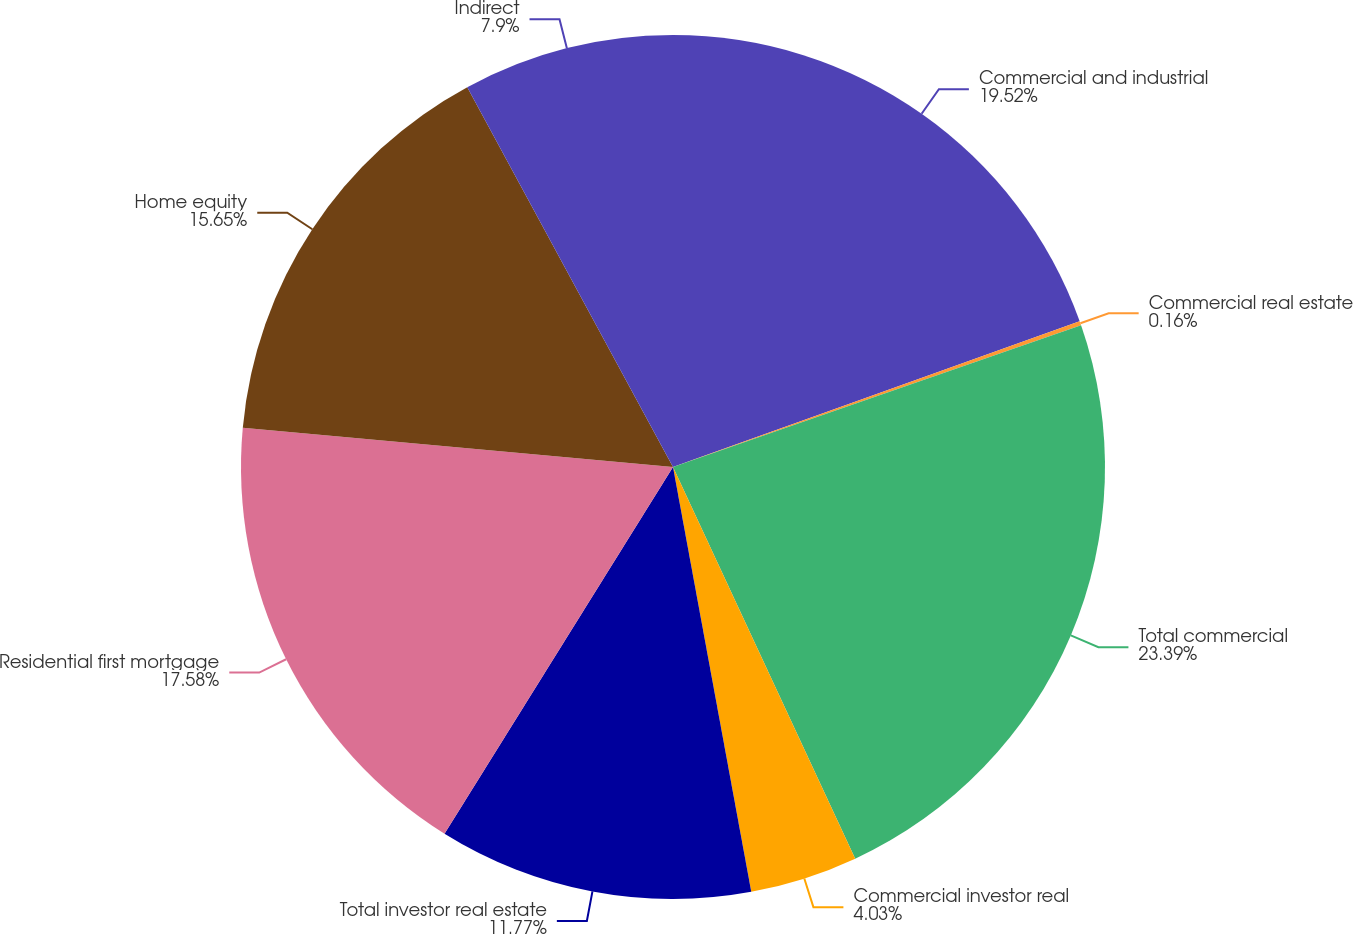Convert chart to OTSL. <chart><loc_0><loc_0><loc_500><loc_500><pie_chart><fcel>Commercial and industrial<fcel>Commercial real estate<fcel>Total commercial<fcel>Commercial investor real<fcel>Total investor real estate<fcel>Residential first mortgage<fcel>Home equity<fcel>Indirect<nl><fcel>19.52%<fcel>0.16%<fcel>23.39%<fcel>4.03%<fcel>11.77%<fcel>17.58%<fcel>15.65%<fcel>7.9%<nl></chart> 